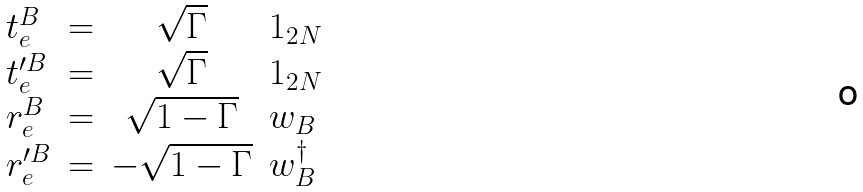Convert formula to latex. <formula><loc_0><loc_0><loc_500><loc_500>\begin{array} { l c c l } t _ { e } ^ { B } & = & \sqrt { \Gamma } & 1 _ { 2 N } \\ t _ { e } ^ { \prime B } & = & \sqrt { \Gamma } & 1 _ { 2 N } \\ r _ { e } ^ { B } & = & \sqrt { 1 - \Gamma } & w _ { B } \\ r _ { e } ^ { \prime B } & = & - \sqrt { 1 - \Gamma } & w _ { B } ^ { \dagger } \end{array}</formula> 